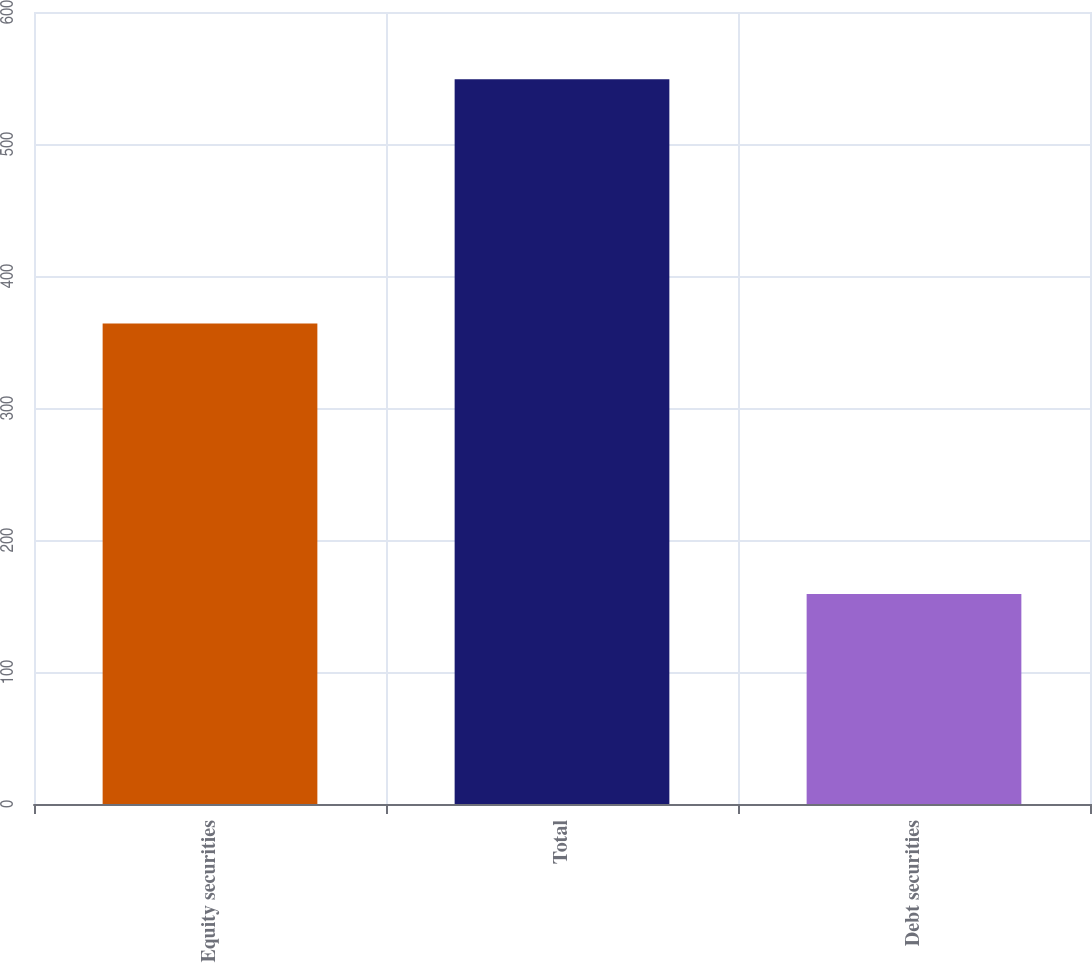Convert chart to OTSL. <chart><loc_0><loc_0><loc_500><loc_500><bar_chart><fcel>Equity securities<fcel>Total<fcel>Debt securities<nl><fcel>364<fcel>549<fcel>159<nl></chart> 